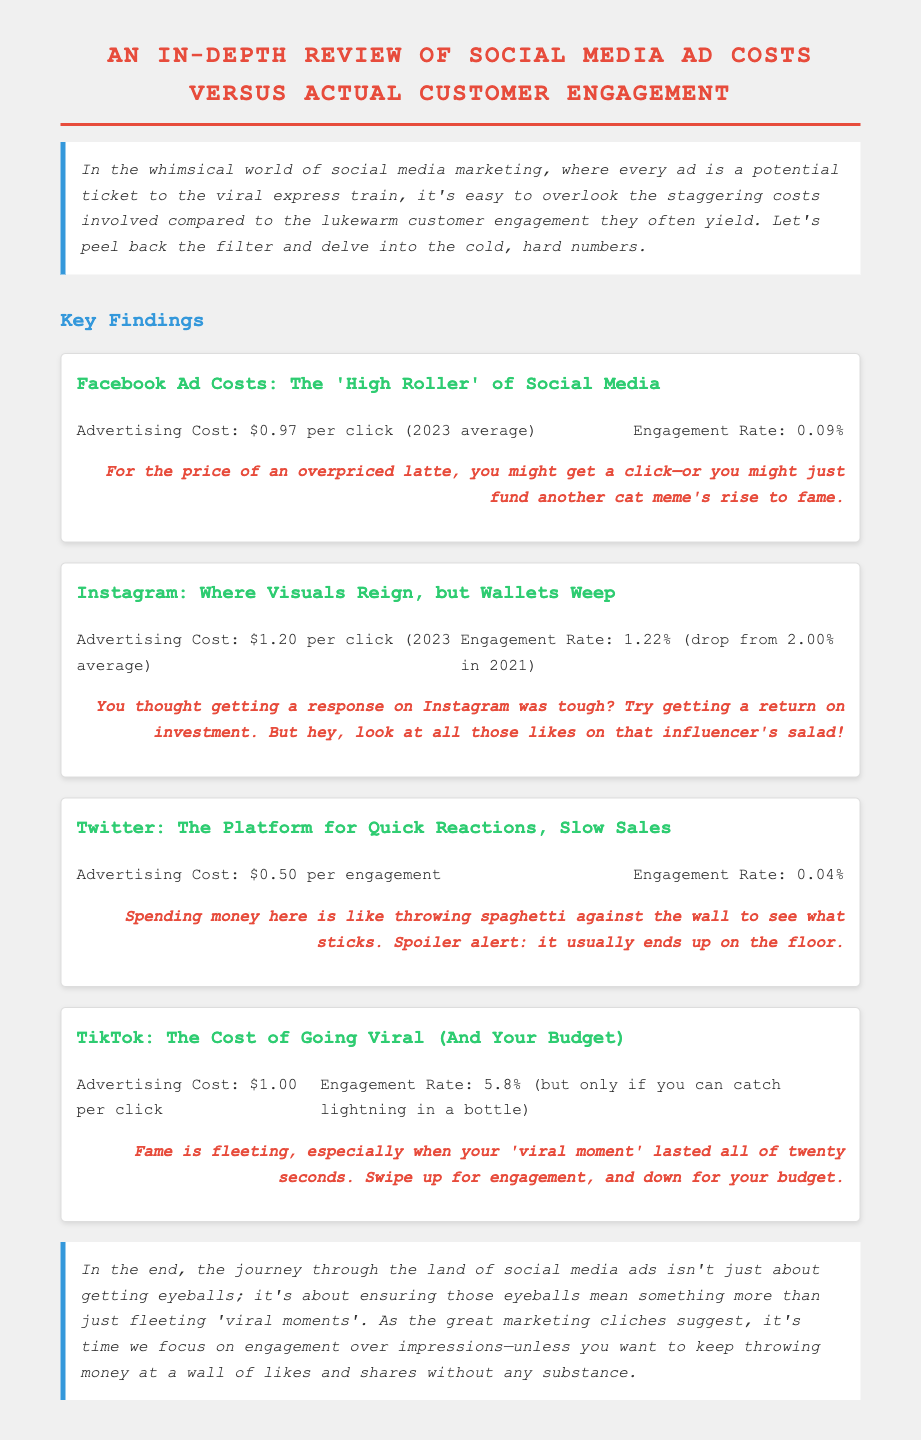What is the advertising cost for Facebook ads? The advertising cost for Facebook ads is specifically mentioned in the document as $0.97 per click (2023 average).
Answer: $0.97 per click What is the engagement rate for Instagram ads? The document states that the engagement rate for Instagram ads has dropped to 1.22% in 2023 from 2.00% in 2021.
Answer: 1.22% What is the advertising cost for Twitter? The document provides the advertising cost for Twitter as $0.50 per engagement.
Answer: $0.50 per engagement What is TikTok's engagement rate? According to the document, TikTok’s engagement rate is 5.8% but it notes that this is conditional on achieving a viral moment.
Answer: 5.8% Which social media platform has the highest advertising cost? By comparing the listed costs, Facebook advertising cost of $0.97 is the highest among the specifics provided.
Answer: Facebook What did Instagram's engagement rate drop from? The document indicates that Instagram's engagement rate fell from 2.00% in 2021.
Answer: 2.00% What is the snarky commentary for Twitter ads? The sarcasm for Twitter ads mentions "throwing spaghetti against the wall to see what sticks," implying a low chance of success.
Answer: Throwing spaghetti against the wall How does the conclusion suggest marketers should approach social media ads? The conclusion recommends focusing on engagement rather than just impressions, highlighting the desired strategy shift.
Answer: Engagement over impressions What does the document state is the cost of a TikTok click? The specific cost for a TikTok click is clearly outlined in the document as $1.00.
Answer: $1.00 per click 